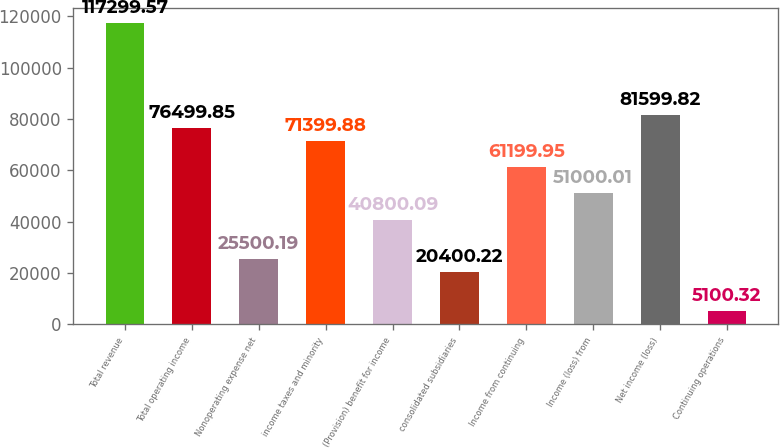Convert chart to OTSL. <chart><loc_0><loc_0><loc_500><loc_500><bar_chart><fcel>Total revenue<fcel>Total operating income<fcel>Nonoperating expense net<fcel>income taxes and minority<fcel>(Provision) benefit for income<fcel>consolidated subsidiaries<fcel>Income from continuing<fcel>Income (loss) from<fcel>Net income (loss)<fcel>Continuing operations<nl><fcel>117300<fcel>76499.9<fcel>25500.2<fcel>71399.9<fcel>40800.1<fcel>20400.2<fcel>61199.9<fcel>51000<fcel>81599.8<fcel>5100.32<nl></chart> 